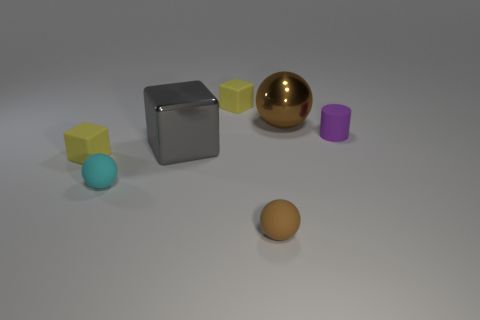Add 1 big gray things. How many objects exist? 8 Subtract all blocks. How many objects are left? 4 Add 4 cylinders. How many cylinders exist? 5 Subtract 0 brown blocks. How many objects are left? 7 Subtract all metallic blocks. Subtract all small matte things. How many objects are left? 1 Add 4 big brown things. How many big brown things are left? 5 